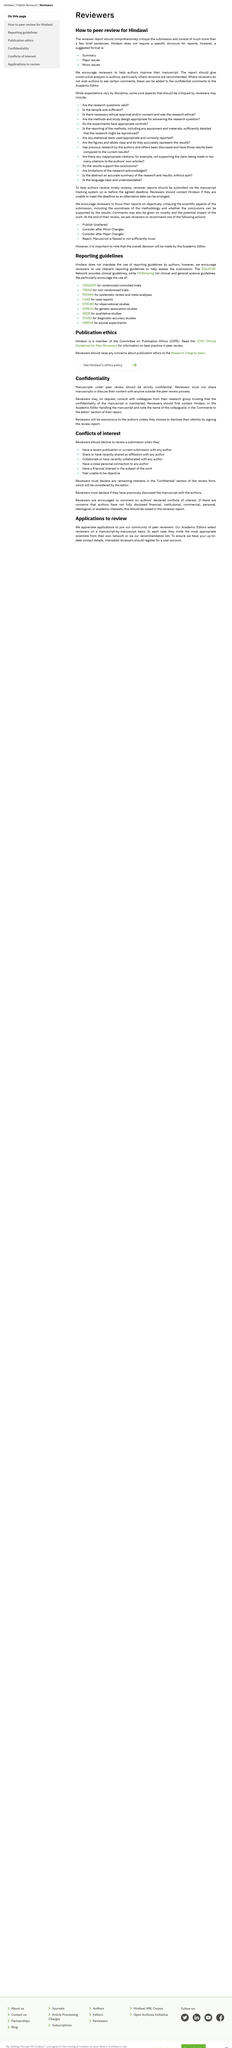Highlight a few significant elements in this photo. The process of peer review provides authors with the opportunity to improve their manuscripts with the guidance and feedback of experienced reviewers. The recommended format for reports in Hindawi is to include a summary, major issues, and minor issues. It is mandatory for reviews to disclose any remaining interests in the 'Confidential' section of the review form. Hindawi encourages its reviewers to use relevant reporting guidelines to help assess submissions. Peer reviewers should look for validity in a research question during the peer review process. 